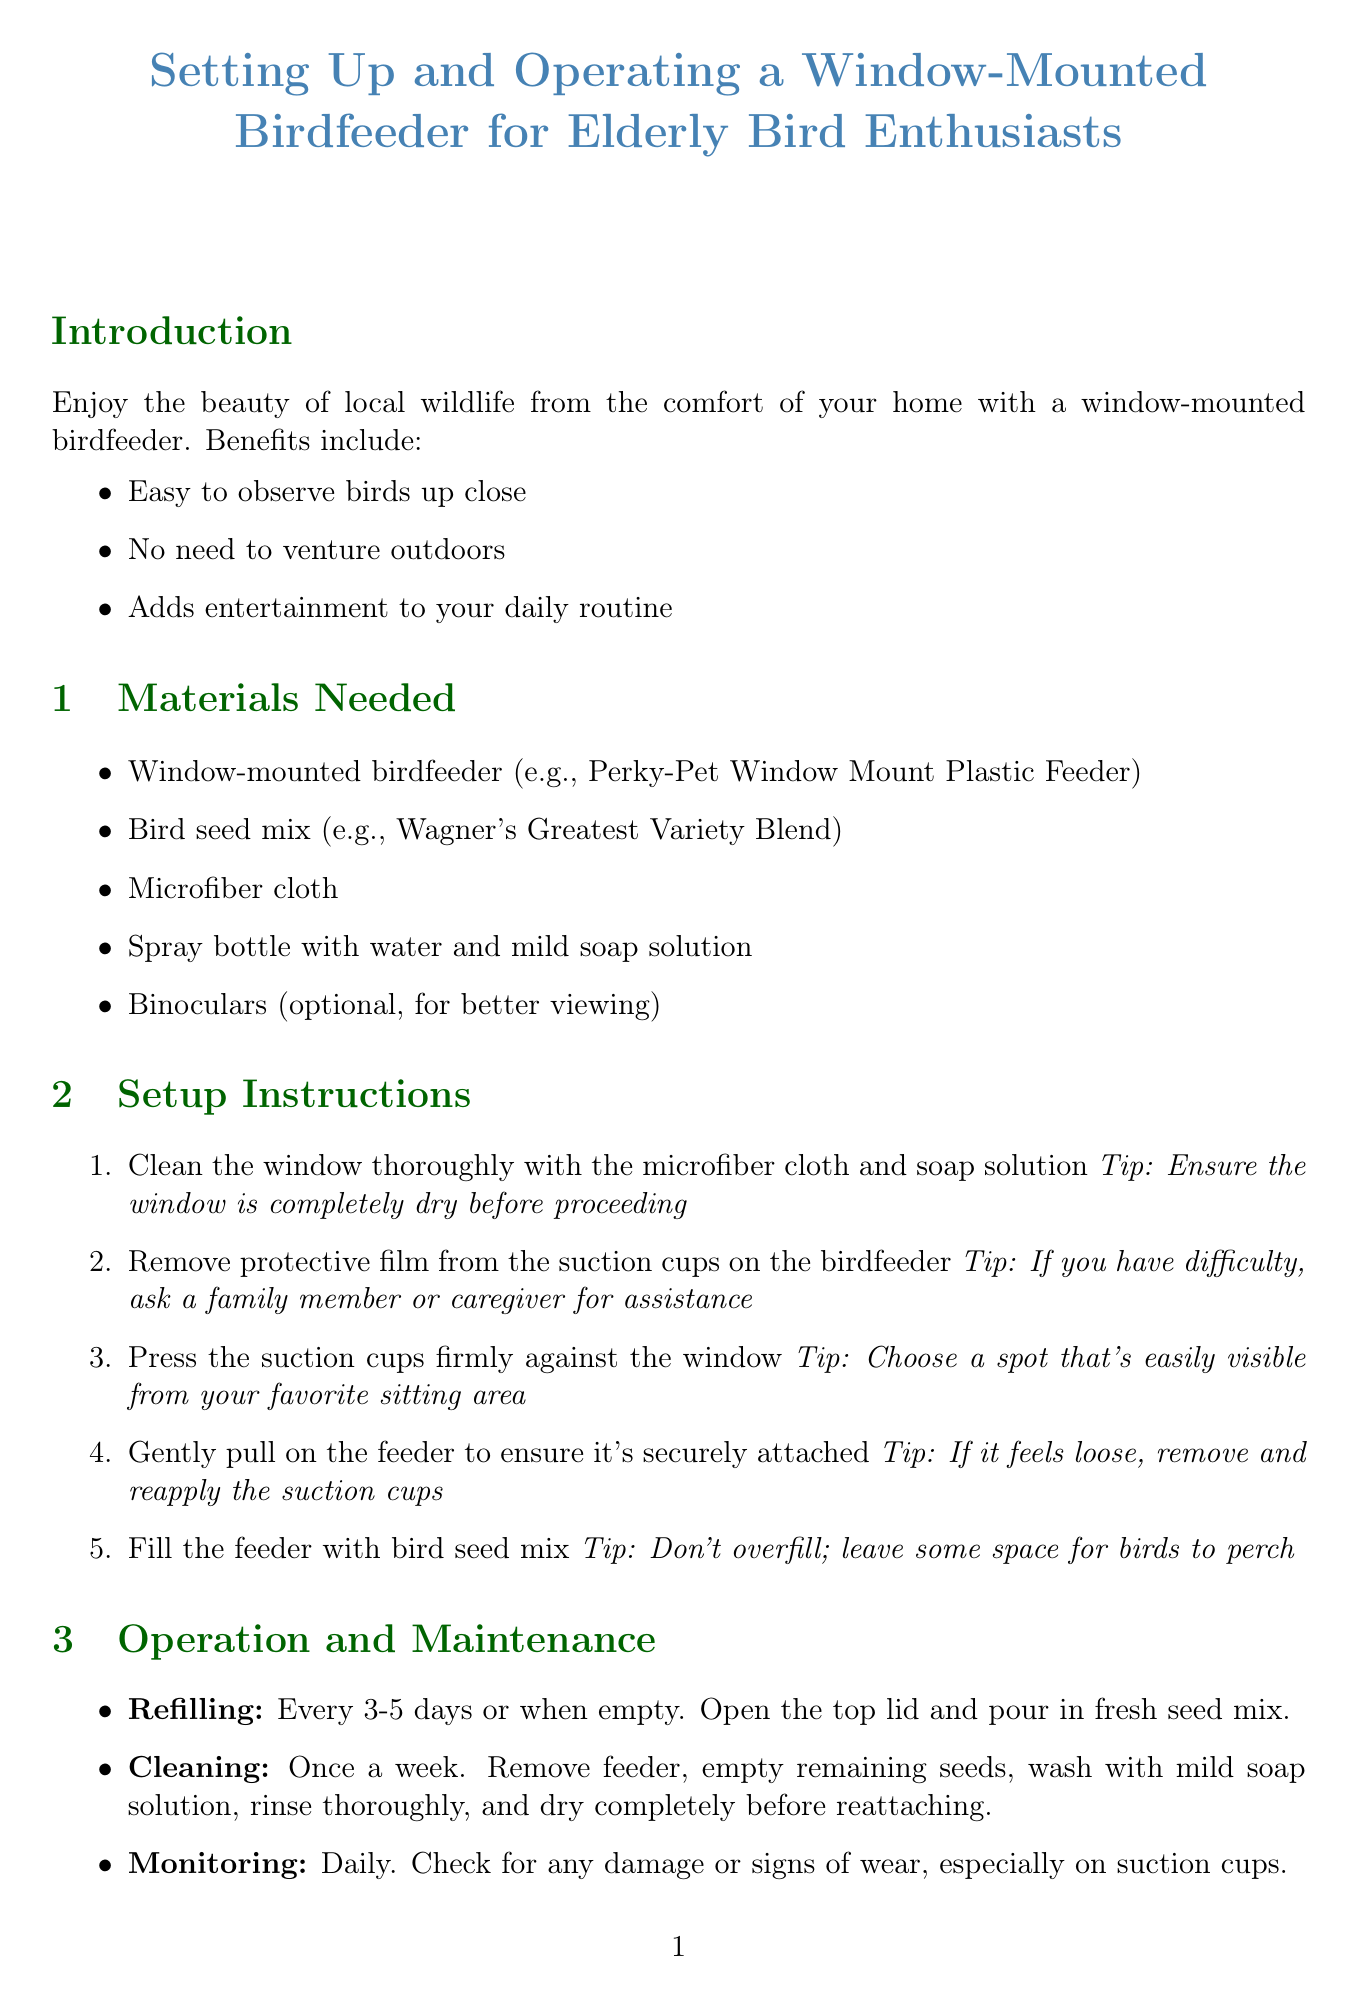what is the title of the manual? The title of the manual is stated at the beginning of the document.
Answer: Setting Up and Operating a Window-Mounted Birdfeeder for Elderly Bird Enthusiasts how often should the feeder be cleaned? The manual specifies the frequency of cleaning in the operation and maintenance section.
Answer: Once a week what type of feeder is recommended? The document specifies an example of a suitable feeder in the materials needed section.
Answer: Perky-Pet Window Mount Plastic Feeder which bird prefers nyjer seeds? The common local birds section lists the preferred foods for different birds.
Answer: American Goldfinch what should you do if the feeder feels loose? This is mentioned in the setup instructions where securing the feeder is advised.
Answer: Remove and reapply the suction cups how can you attract different bird species? The manual lists suggestions in the attracting birds section regarding food variety.
Answer: Use a variety of seeds what is one safety consideration mentioned? The safety considerations section includes tasks to ensure safe setup and maintenance.
Answer: Ensure the feeder is securely attached to prevent falls what item is suggested for better bird watching? The materials needed section includes optional items for enhanced viewing.
Answer: Binoculars how can you enhance your birdwatching experience? The enjoyment tips section contains recommendations for enjoyable birdwatching.
Answer: Share your birdwatching experiences with friends during your lively parties 